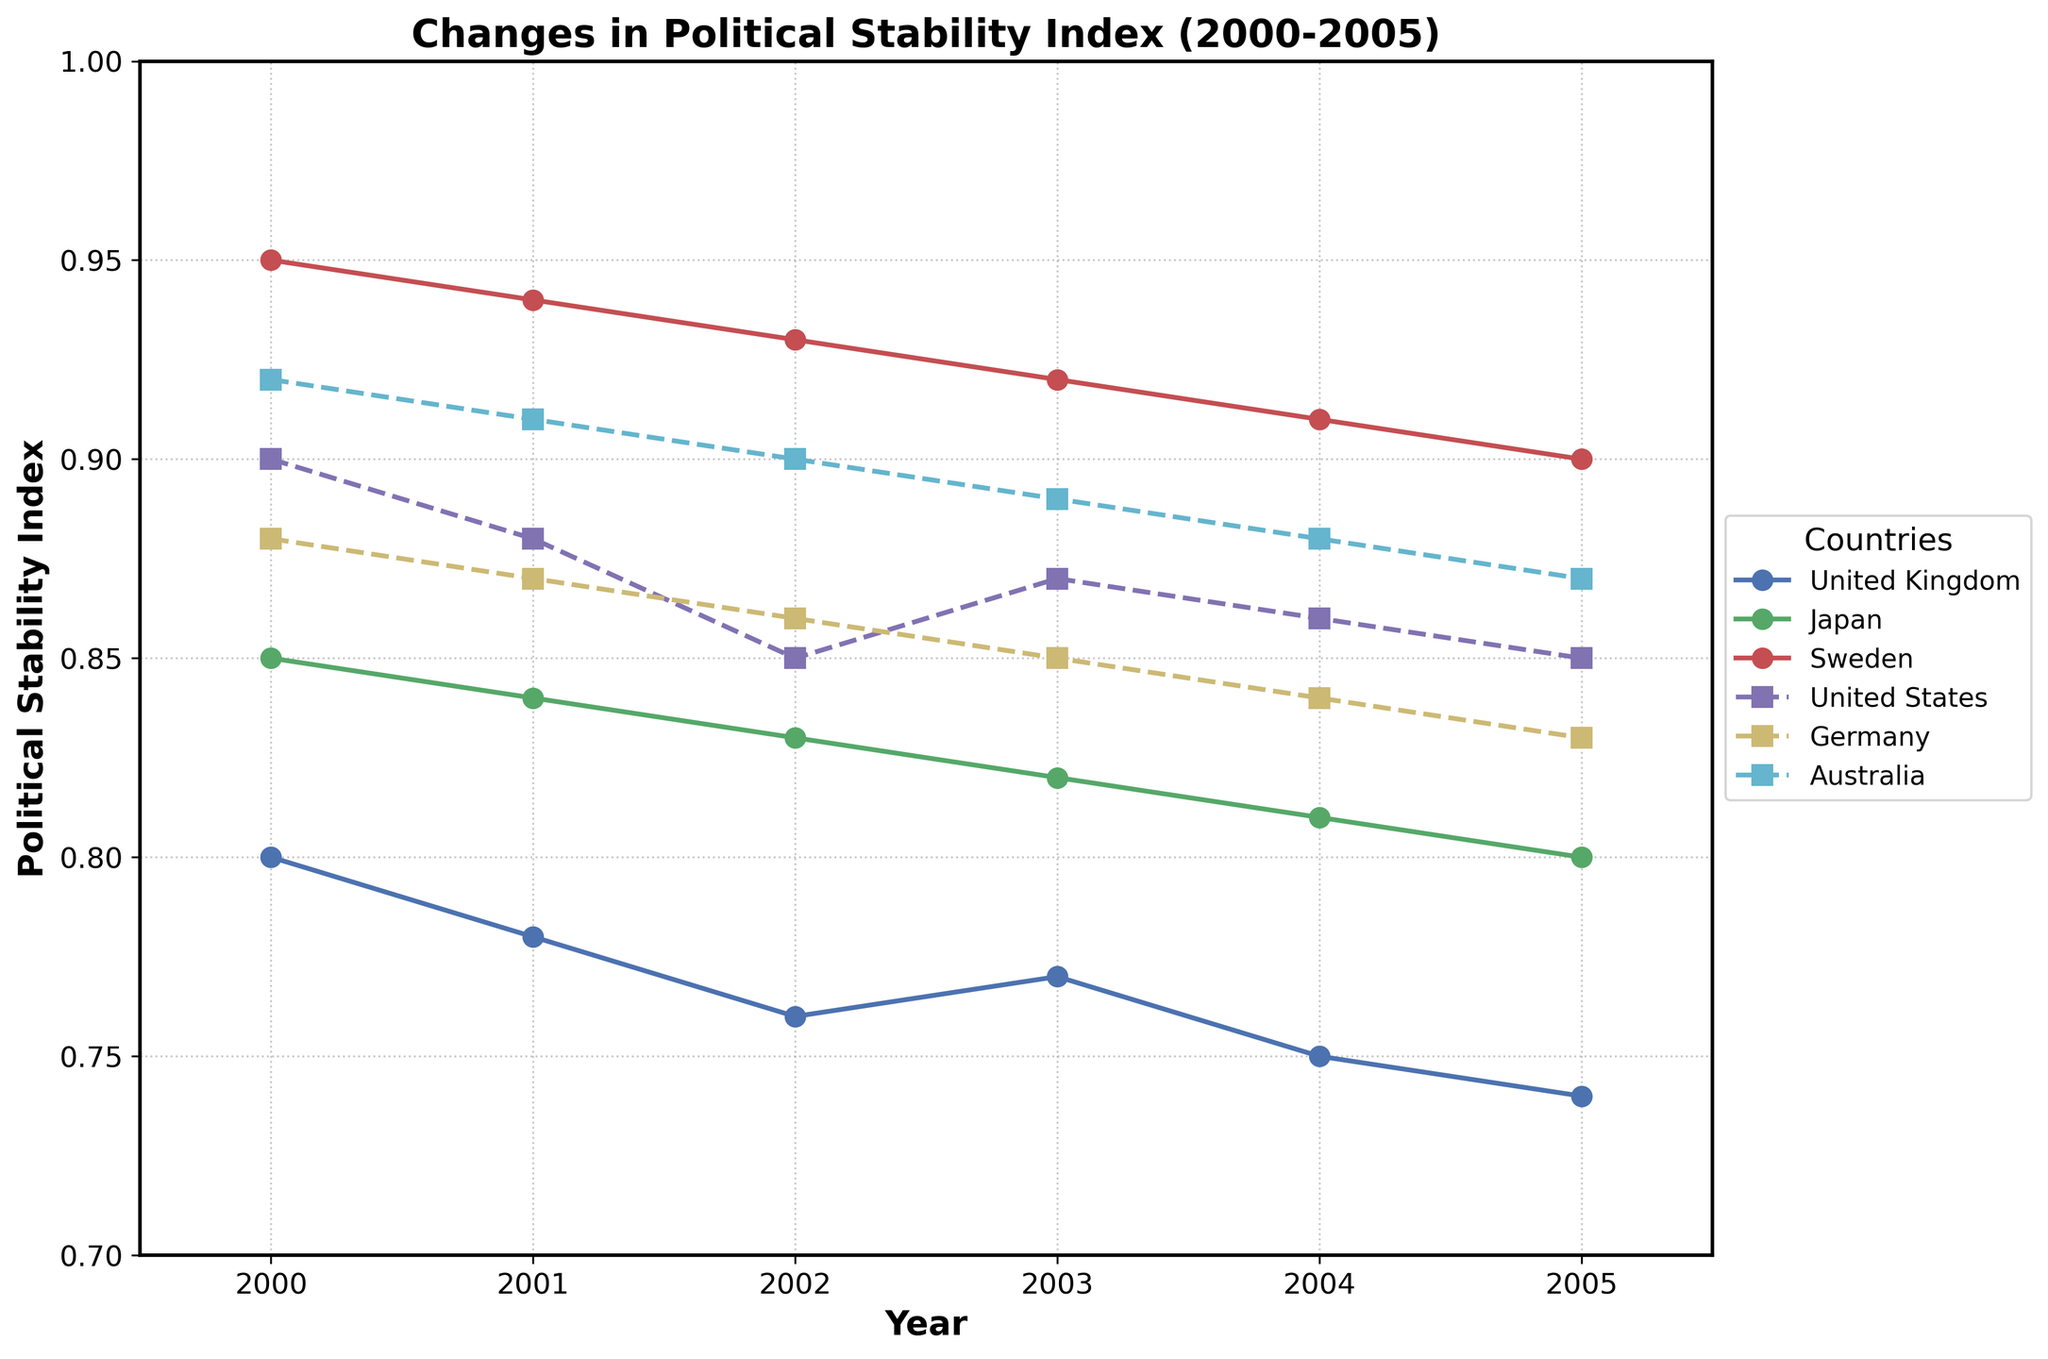What is the title of the figure? The title is displayed at the top of the figure. It describes the overall theme or focus of the plot.
Answer: Changes in Political Stability Index (2000-2005) Which country with hereditary leadership has the highest Political Stability Index in 2005? To determine this, examine the data points for countries with hereditary leadership and identify the country with the highest value in the year 2005.
Answer: Sweden How does the Political Stability Index of the United States change from 2000 to 2005? Check the line representing the United States and observe the data points from 2000 to 2005 to note the changes in values.
Answer: It decreases from 0.90 to 0.85 Which country experienced the biggest drop in Political Stability Index between 2000 and 2005? Calculate the difference between 2000 and 2005 for each country. Identify the country with the largest decrease.
Answer: Germany In 2003, which country with non-hereditary leadership had the highest Political Stability Index? From the lines representing non-hereditary countries, check the values for the year 2003 and identify the highest one.
Answer: United States What general trend can be observed in countries with hereditary leadership in terms of their Political Stability Index from 2000 to 2005? Observe the lines representing countries with hereditary leadership and describe the general movement of the indices over time.
Answer: Gradual decrease Comparing Japan and the United Kingdom, which country had a higher Political Stability Index in 2002? Compare the data points for Japan and the United Kingdom for the year 2002.
Answer: Japan What is the average Political Stability Index of Australia over the period 2000-2005? Sum the Political Stability Index values for Australia across the years and then divide by the number of years to find the average. (0.92 + 0.91 + 0.90 + 0.89 + 0.88 + 0.87) / 6
Answer: 0.895 Between 2000 and 2005, which country with hereditary leadership shows the most stability in its Political Stability Index? Determine which hereditary country has the least variation in its Political Stability Index values over the years.
Answer: Sweden What is the difference in Political Stability Index between Japan and Australia in 2005? Subtract the index value of Australia from that of Japan for the year 2005. (0.80 - 0.87)
Answer: -0.07 